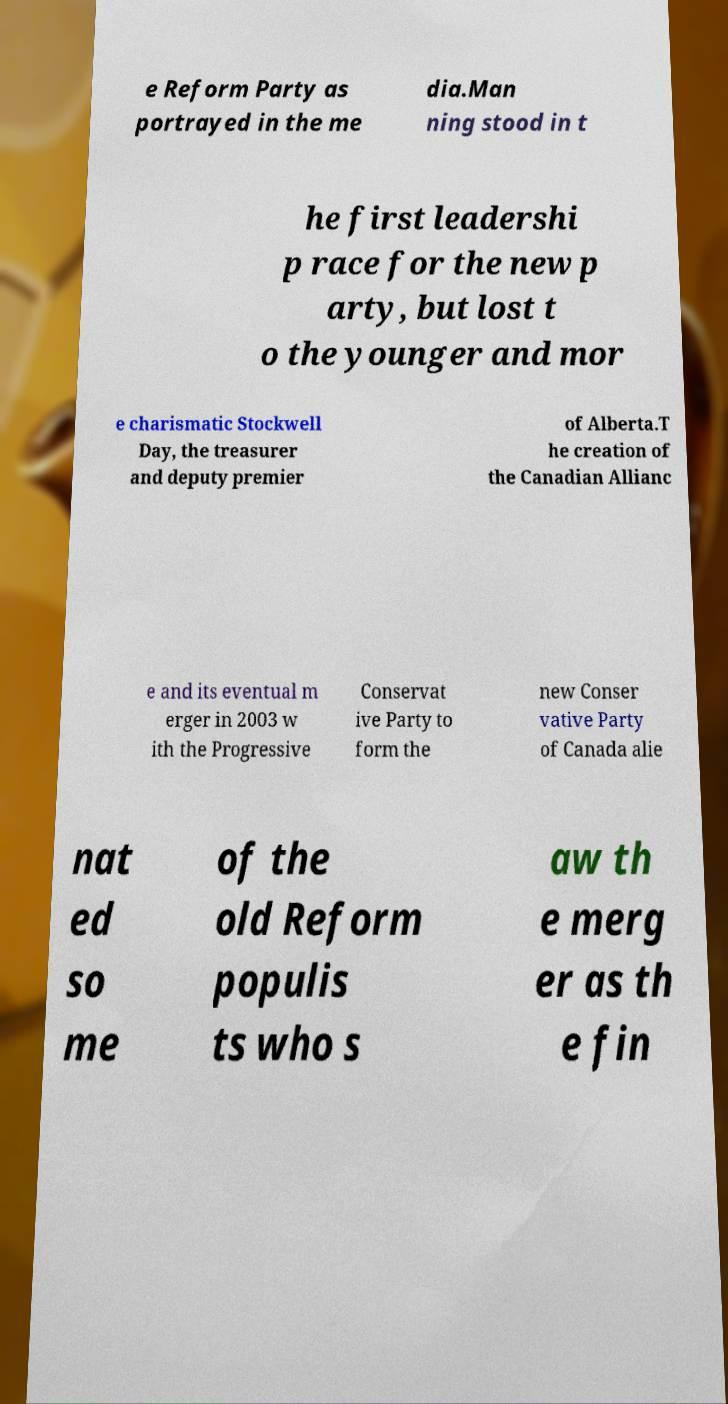I need the written content from this picture converted into text. Can you do that? e Reform Party as portrayed in the me dia.Man ning stood in t he first leadershi p race for the new p arty, but lost t o the younger and mor e charismatic Stockwell Day, the treasurer and deputy premier of Alberta.T he creation of the Canadian Allianc e and its eventual m erger in 2003 w ith the Progressive Conservat ive Party to form the new Conser vative Party of Canada alie nat ed so me of the old Reform populis ts who s aw th e merg er as th e fin 